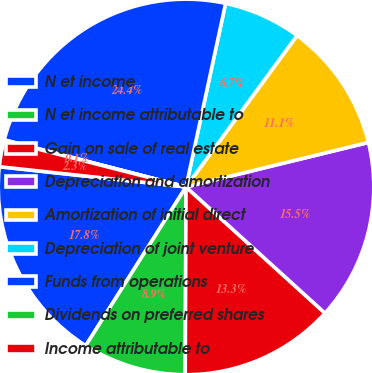Convert chart to OTSL. <chart><loc_0><loc_0><loc_500><loc_500><pie_chart><fcel>N et income<fcel>N et income attributable to<fcel>Gain on sale of real estate<fcel>Depreciation and amortization<fcel>Amortization of initial direct<fcel>Depreciation of joint venture<fcel>Funds from operations<fcel>Dividends on preferred shares<fcel>Income attributable to<nl><fcel>17.75%<fcel>8.9%<fcel>13.33%<fcel>15.54%<fcel>11.12%<fcel>6.69%<fcel>24.35%<fcel>0.05%<fcel>2.26%<nl></chart> 